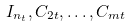<formula> <loc_0><loc_0><loc_500><loc_500>I _ { n _ { t } } , C _ { 2 t } , \dots , C _ { m t }</formula> 